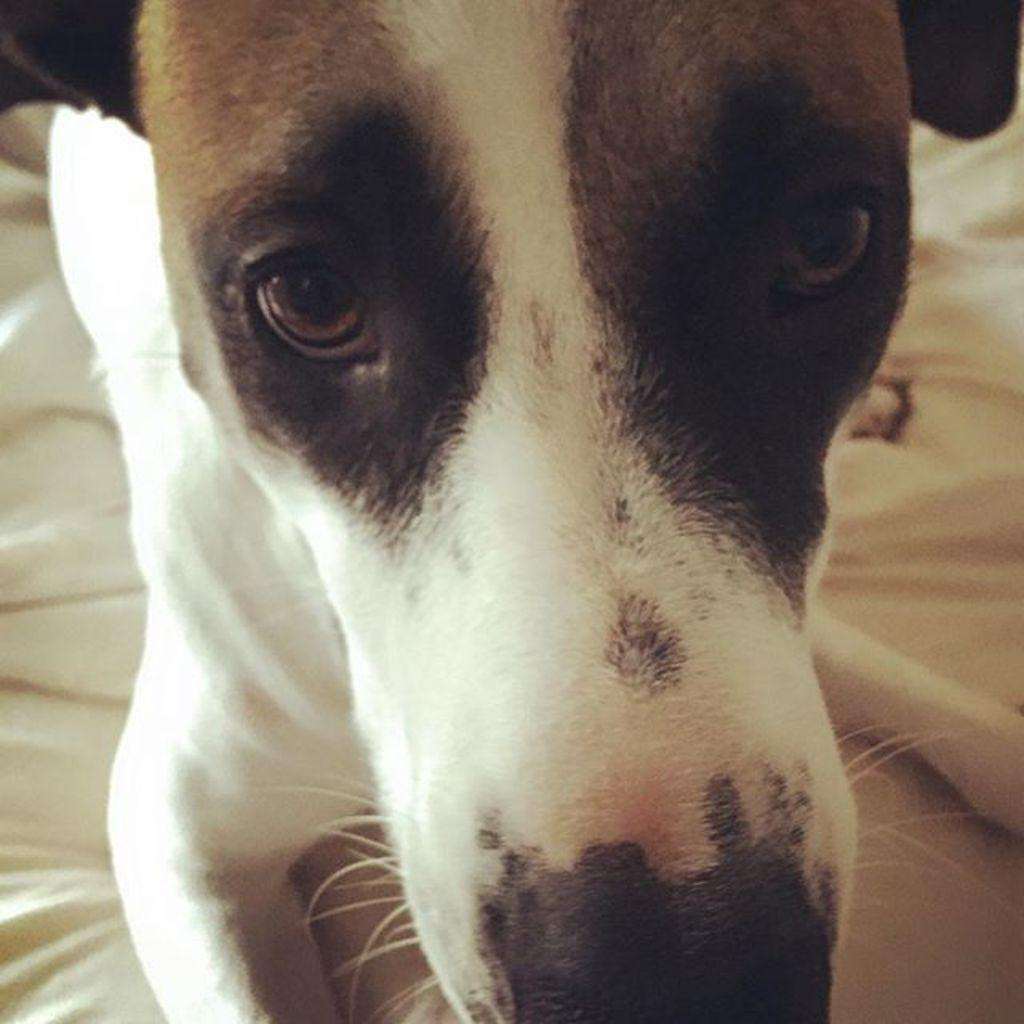What animal is present in the image? There is a dog in the image. Where is the dog located? The dog is sitting on a bed. Can you see any visible veins on the dog in the image? There is no mention of visible veins on the dog in the image, and it is not possible to determine this from the provided facts. 